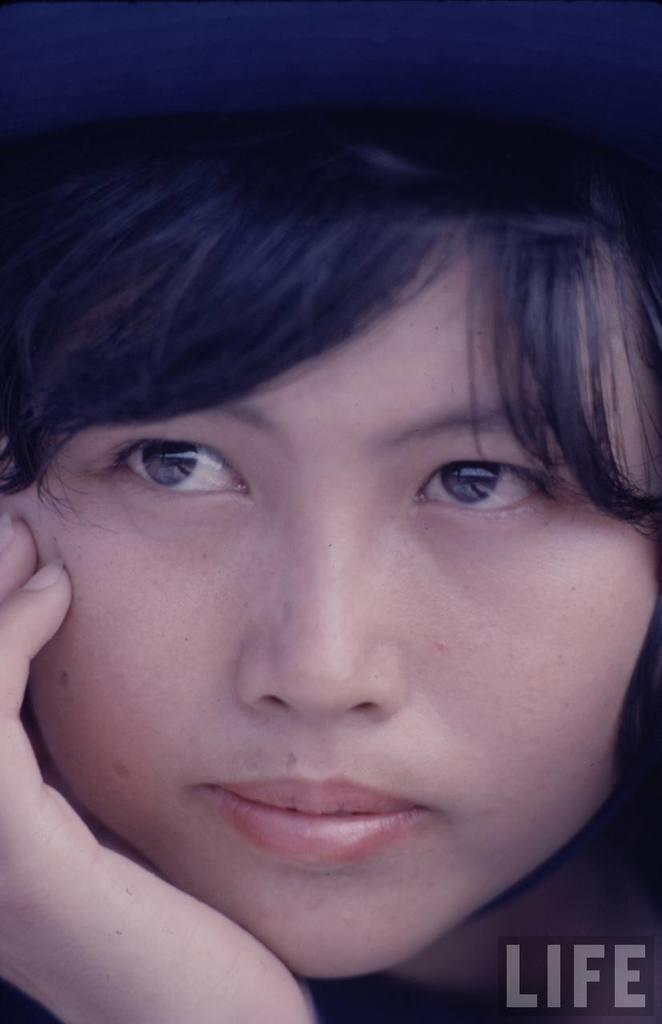What part of a person is visible in the image? There is a person's face in the image. What else can be seen related to a person in the image? There is a person's hand in the image. Where is the text located in the image? The text is at the right bottom of the image. What type of house is visible in the image? There is no house present in the image. What is the person's mouth doing in the image? The person's mouth is not visible in the image, as only the face and hand are shown. 